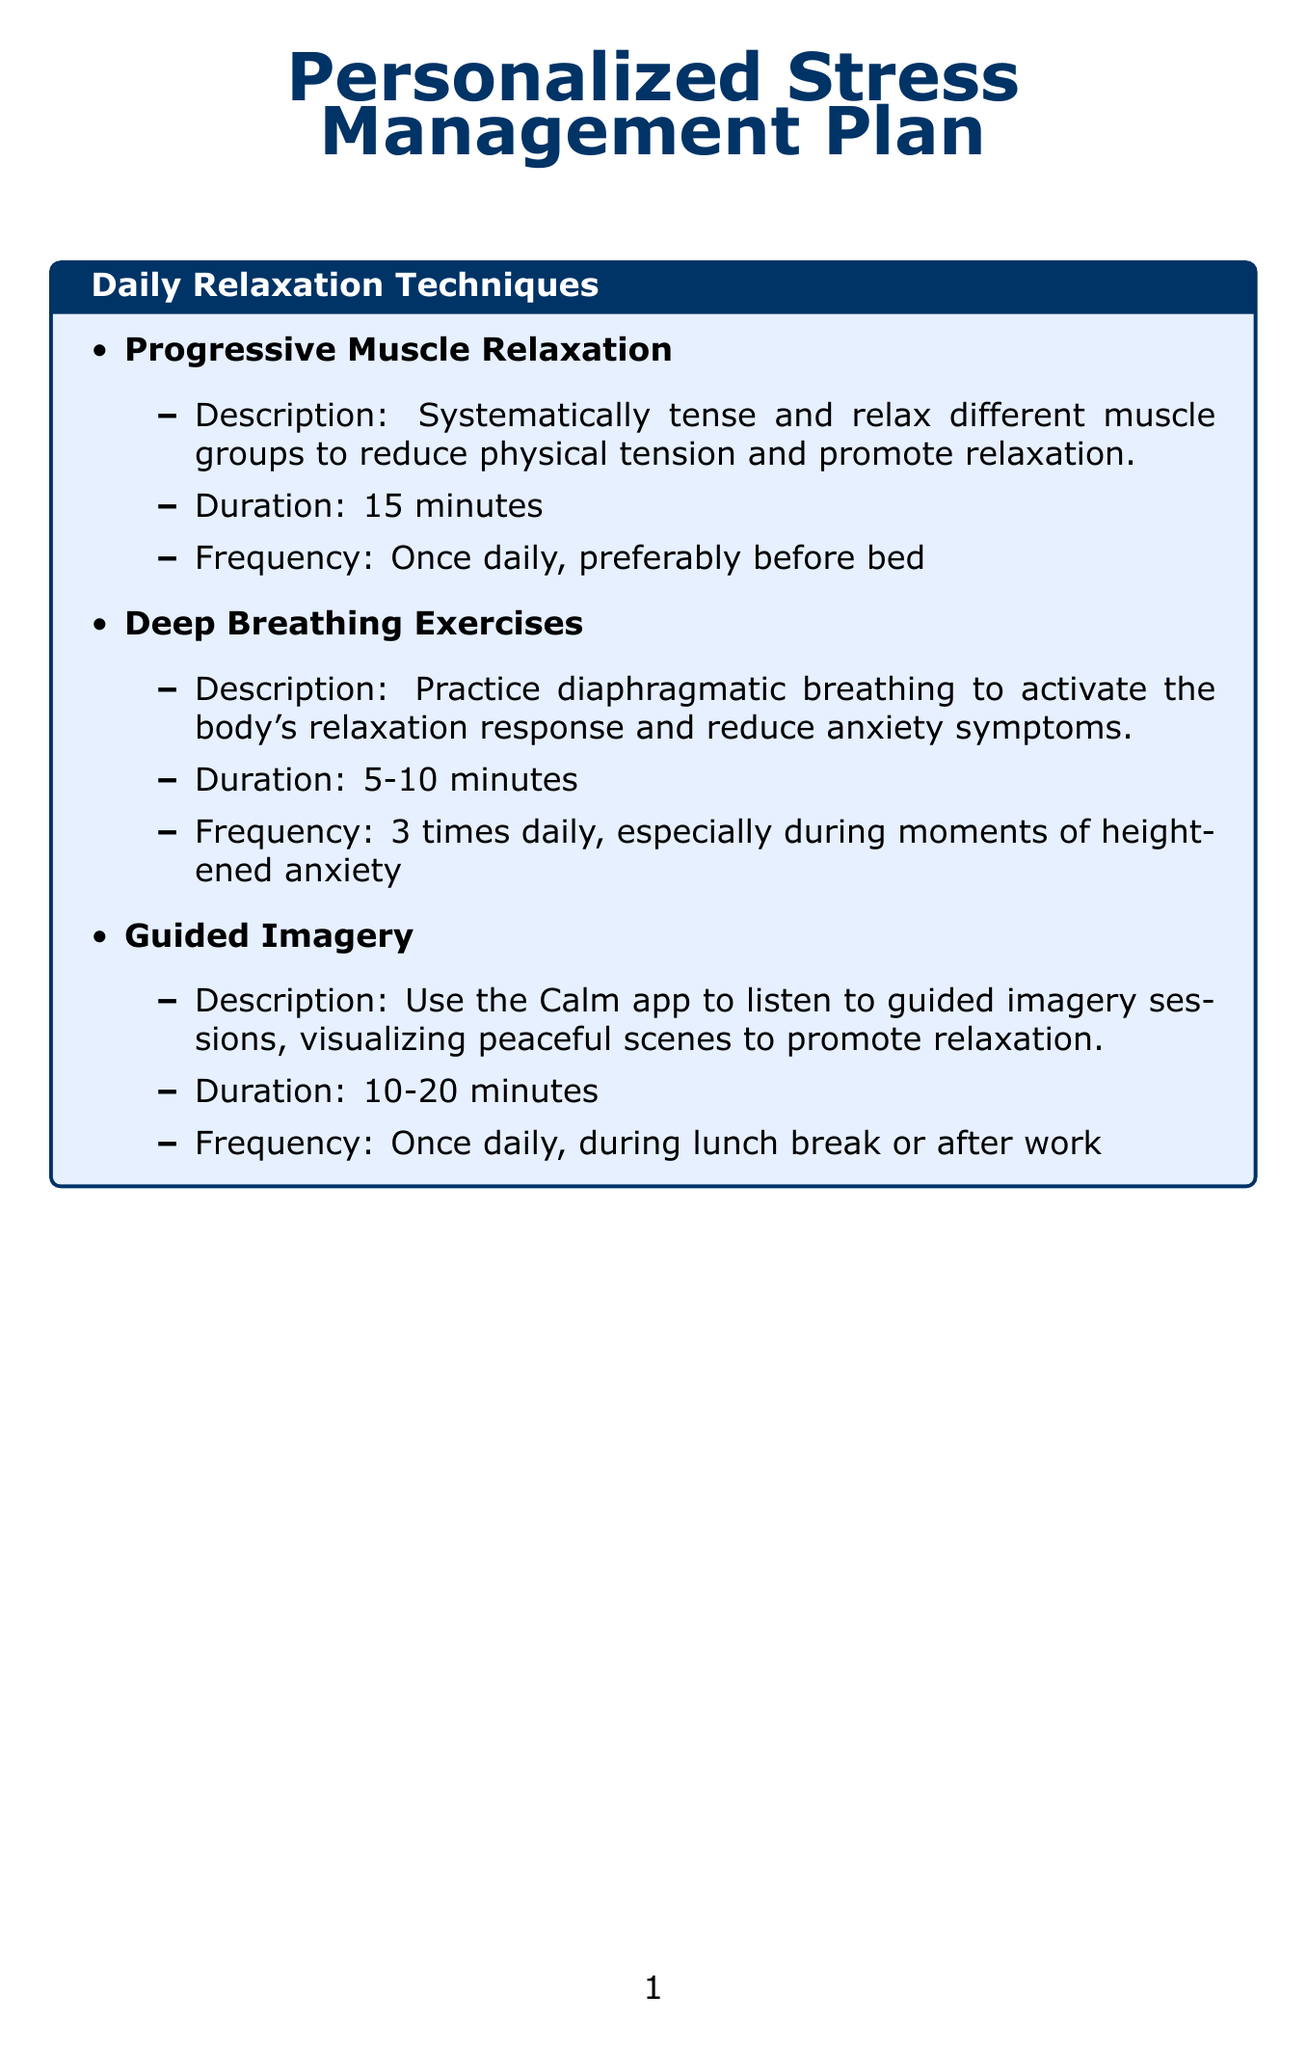what is the duration of Progressive Muscle Relaxation? The duration of Progressive Muscle Relaxation is specified as 15 minutes.
Answer: 15 minutes how many times daily should Deep Breathing Exercises be practiced? The frequency for Deep Breathing Exercises is listed as 3 times daily.
Answer: 3 times daily what is the main goal of Body Scan Meditation? The main goal of Body Scan Meditation is to promote awareness and reduce anxiety-related physical sensations.
Answer: promote awareness and reduce anxiety-related physical sensations how often should Regular Exercise be done per week? Regular Exercise should be done 3-4 times per week according to the plan.
Answer: 3-4 times per week what strategy involves setting aside time each day to address worries? The strategy that involves setting aside time each day to address worries is called Worry Time.
Answer: Worry Time how long should therapy sessions last? The duration of therapy sessions is specified as 50 minutes.
Answer: 50 minutes which activity promotes relaxation and self-expression? The activity that promotes relaxation and self-expression is Hobby Engagement.
Answer: Hobby Engagement what app is suggested for Anxiety Tracking? The suggested app for Anxiety Tracking is MoodNotes.
Answer: MoodNotes what frequency is recommended for Social Connection activities? The recommended frequency for Social Connection activities is at least once per week.
Answer: at least once per week 